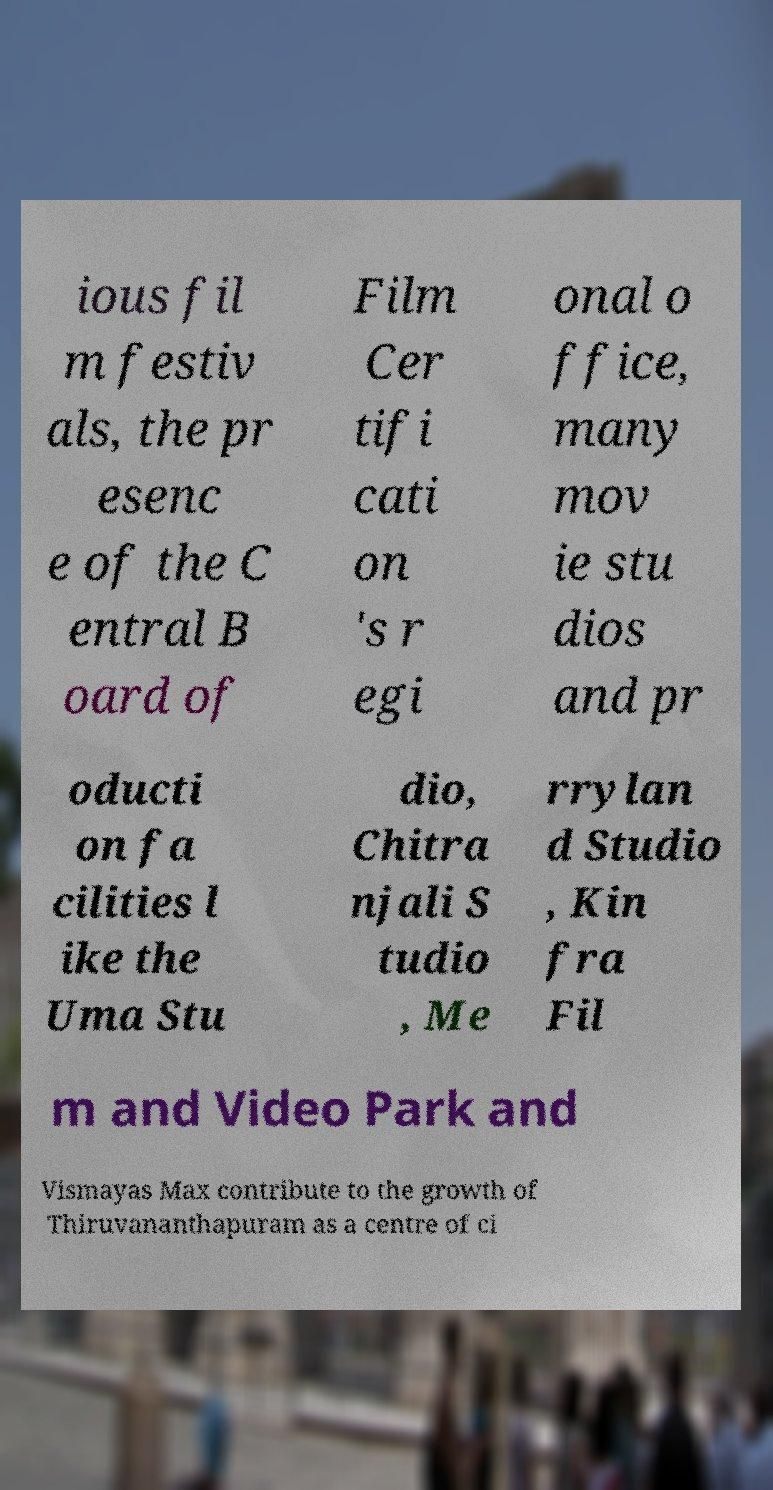Can you read and provide the text displayed in the image?This photo seems to have some interesting text. Can you extract and type it out for me? ious fil m festiv als, the pr esenc e of the C entral B oard of Film Cer tifi cati on 's r egi onal o ffice, many mov ie stu dios and pr oducti on fa cilities l ike the Uma Stu dio, Chitra njali S tudio , Me rrylan d Studio , Kin fra Fil m and Video Park and Vismayas Max contribute to the growth of Thiruvananthapuram as a centre of ci 